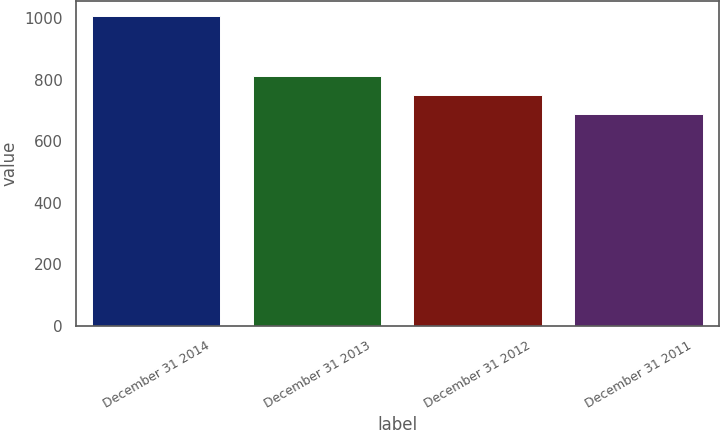<chart> <loc_0><loc_0><loc_500><loc_500><bar_chart><fcel>December 31 2014<fcel>December 31 2013<fcel>December 31 2012<fcel>December 31 2011<nl><fcel>1005<fcel>810<fcel>749<fcel>689<nl></chart> 